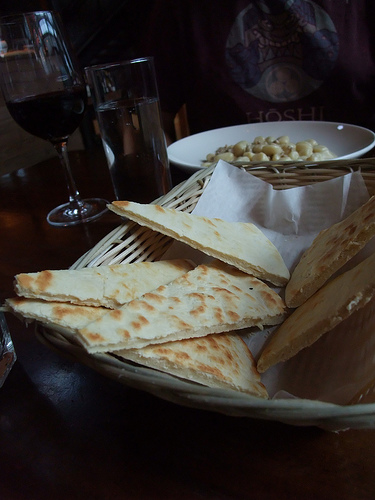<image>
Is the glass above the bread? No. The glass is not positioned above the bread. The vertical arrangement shows a different relationship. 